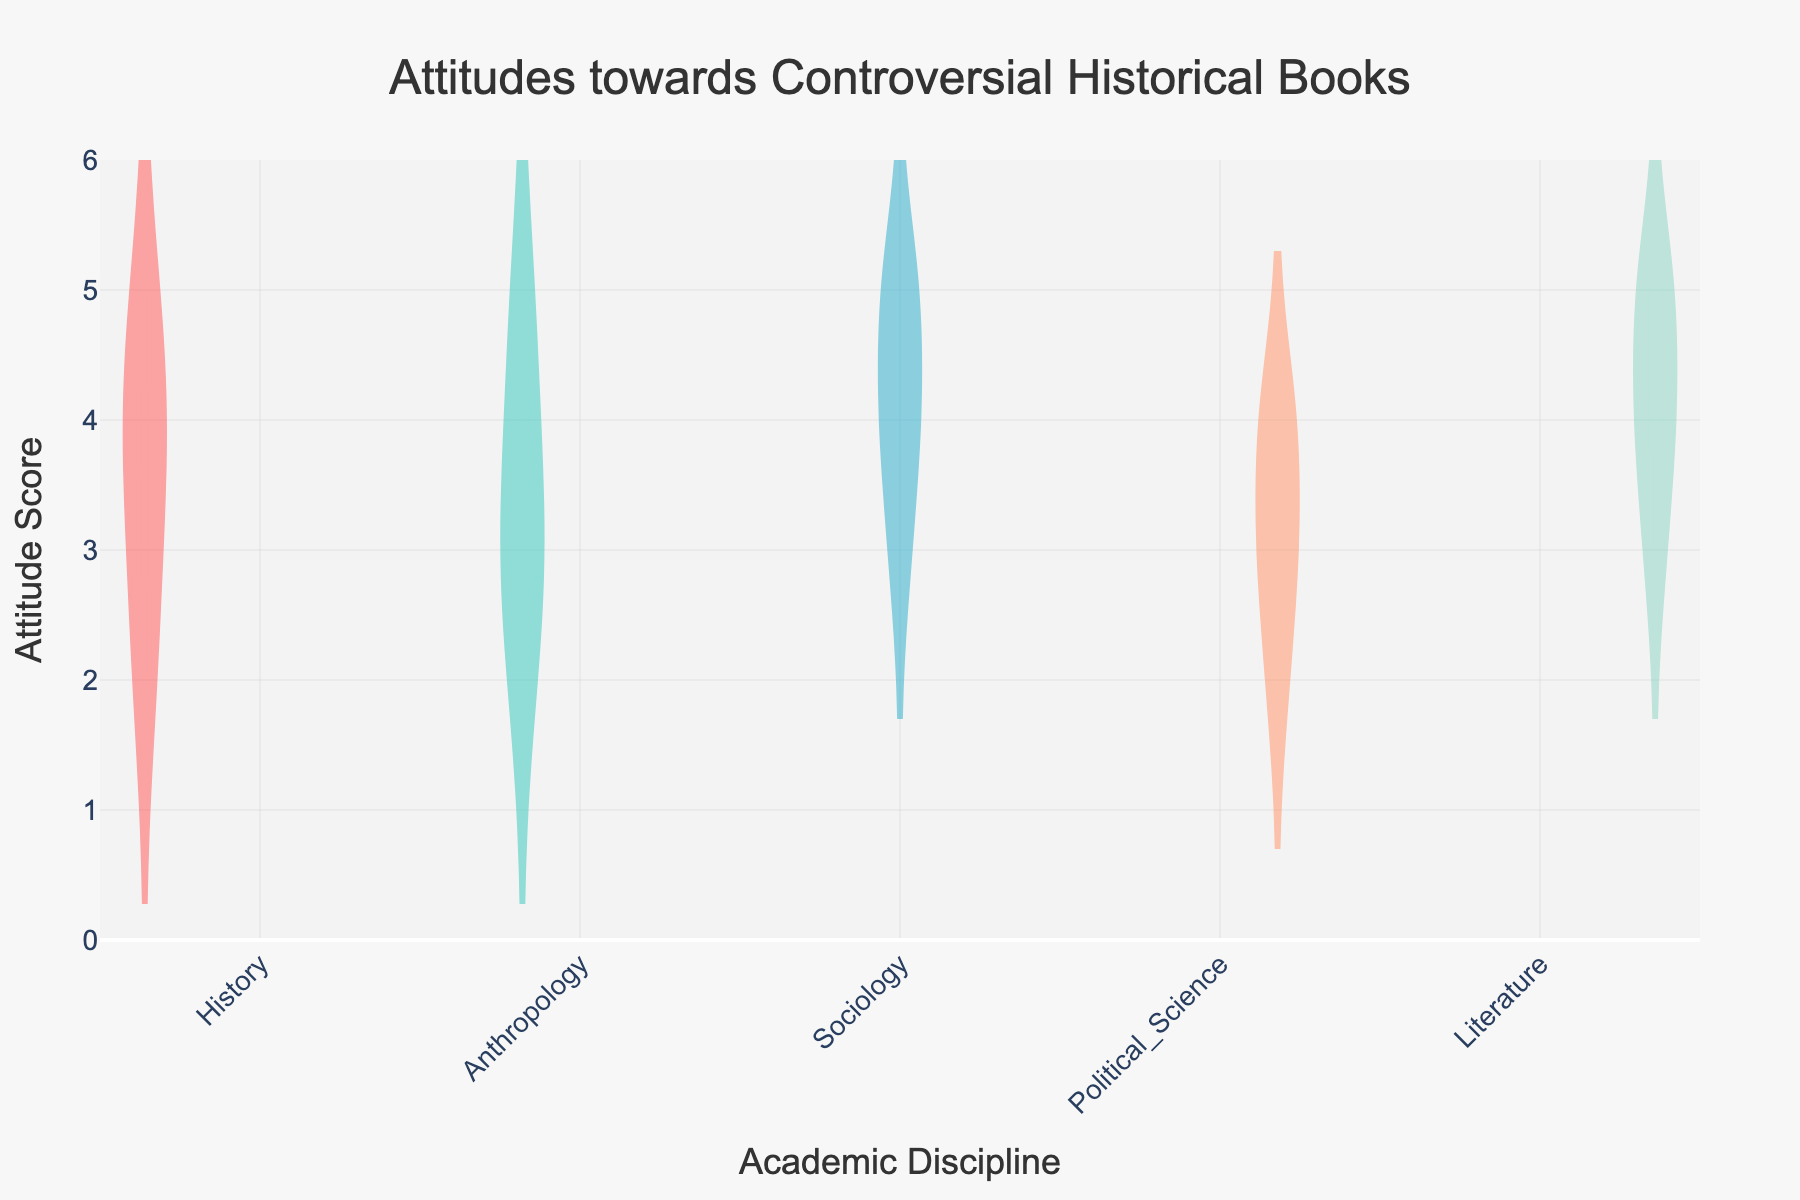What is the title of the figure? The title of the figure is displayed prominently at the top, indicating the subject of the visualization.
Answer: Attitudes towards Controversial Historical Books Which academic discipline has the highest median attitude score? The box portion of the violin plot shows the median as the line inside the box. In the figure, Literature has the box positioned highest along the vertical axis, indicating the highest median score.
Answer: Literature How many disciplines are represented in the figure? Each unique category on the horizontal axis represents a different discipline. By counting these categories, we see that five disciplines are represented.
Answer: Five What is the range of attitude scores for the History discipline? The range can be determined by looking at the span of the violin plot from the lowest to the highest point within the History category. The minimum score is 2 and the maximum score is 5, giving a range of 3.
Answer: 3 Which discipline has the widest distribution of attitude scores? The width of the violin plot indicates the distribution spread. In the figure, Anthropology's plot is noticeably wider, suggesting a greater variability in scores.
Answer: Anthropology What is the interquartile range (IQR) of the Sociology discipline? The IQR is shown by the length of the box in the box plot portion of the violin plot. For Sociology, the box extends from 4 (Q1) to 5 (Q3), so the IQR is Q3 - Q1 = 5 - 4 = 1.
Answer: 1 Which disciplines have the same median attitude score? The median score is represented by the central line in each box plot. By visually comparing their positions, we find that Sociology and Political Science both have a median score of 4.
Answer: Sociology and Political Science Are there any outliers in the Literature discipline? Outliers are typically indicated by points outside the whiskers of the box plot within the violin plot. By inspecting the Literature plot, there are no points outside the whiskers, so there are no outliers.
Answer: No What is the mean attitude score for the Political Science discipline? The mean is represented by a dashed line inside the violin plot. For Political Science, this line is positioned at approximately 3.2.
Answer: 3.2 Which discipline has the least variable attitudes? The variability is indicated by the overall spread of the violin plots and the length of the whiskers. Literature has the narrowest violin plot, suggesting the least variability in attitudes.
Answer: Literature 